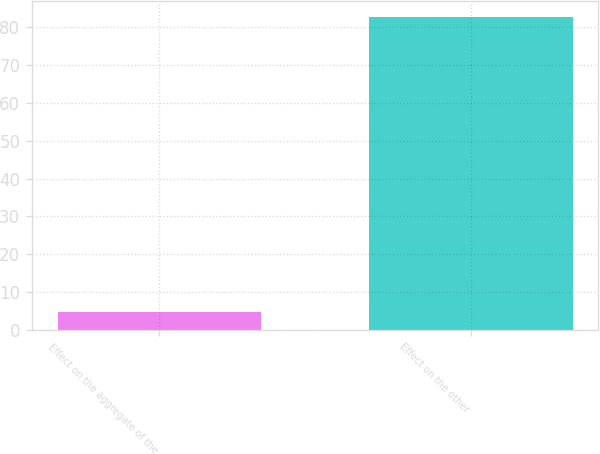Convert chart. <chart><loc_0><loc_0><loc_500><loc_500><bar_chart><fcel>Effect on the aggregate of the<fcel>Effect on the other<nl><fcel>4.7<fcel>82.7<nl></chart> 